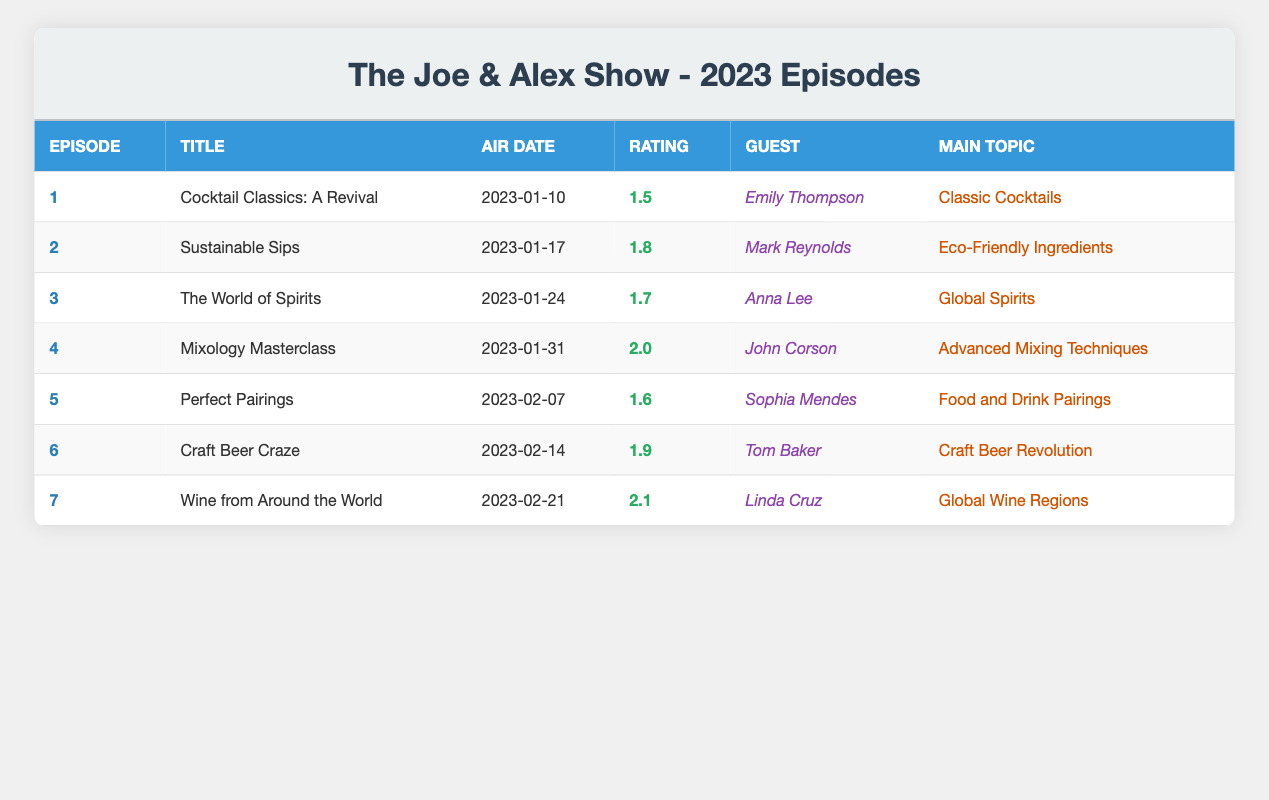What was the viewership rating for the episode titled "Mixology Masterclass"? The viewership rating for "Mixology Masterclass", which is episode number 4, is found in the "Viewership Rating" column, where it shows a rating of 2.0.
Answer: 2.0 Which episode had the highest viewership rating in January 2023? To find the highest rating in January, we look through episodes that aired on January 10, 17, 24, and 31. The ratings are 1.5, 1.8, 1.7, and 2.0 respectively. The highest rating is 2.0 for the episode "Mixology Masterclass".
Answer: 2.0 Did "Wine from Around the World" have a guest appearance? "Wine from Around the World" is episode number 7, and it lists "Linda Cruz" as the guest in the corresponding column, confirming that it had a guest appearance.
Answer: Yes What is the average viewership rating for the first three episodes? The viewership ratings for episodes 1 to 3 are 1.5, 1.8, and 1.7. Summing these gives 1.5 + 1.8 + 1.7 = 5.0. Dividing by the number of episodes (3) results in an average of 5.0 / 3 = approximately 1.67.
Answer: 1.67 Which episode focused on eco-friendly ingredients? The episode titled "Sustainable Sips" is episode number 2, and it focuses on eco-friendly ingredients as indicated in the "Main Topic" column.
Answer: Sustainable Sips How many episodes aired before February 2023? The episodes that aired in January 2023 include episodes 1 through 4 (from January 10 to January 31). Counting these gives a total of 4 episodes before February.
Answer: 4 Was there an episode that had a viewership rating of 1.6? Looking through the viewership ratings in the table, episode 5, titled "Perfect Pairings", has a viewership rating of 1.6. Therefore, there was indeed an episode with this rating.
Answer: Yes What is the total viewership rating for the episodes aired in February? The episodes aired in February 2023 include episodes 5, 6, and 7. Their ratings are 1.6, 1.9, and 2.1, respectively. Adding these ratings gives 1.6 + 1.9 + 2.1 = 5.6, which is the total.
Answer: 5.6 Which episode had the lowest viewership rating? The ratings for all episodes are compared, revealing that episode 1, titled "Cocktail Classics: A Revival", has the lowest rating at 1.5.
Answer: 1.5 